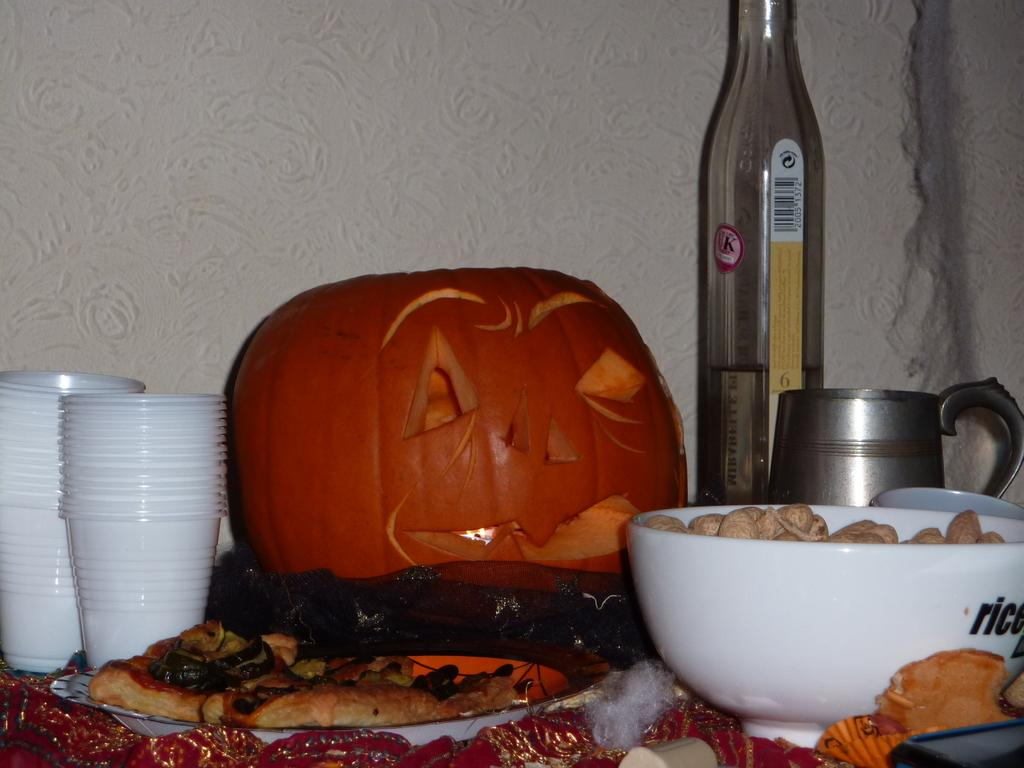What type of containers are visible in the image? There are cups in the image. What else can be seen on the table in the image? There is food on a plate and food in a bowl in the image. What seasonal item is present in the image? There is a pumpkin in the image. What type of beverage container is visible in the image? There is a bottle in the image. What color is the cloth at the bottom of the image? The cloth at the bottom of the image is red. How many army units are present in the image? There are no army units present in the image. What type of nest can be seen in the image? There is no nest present in the image. 